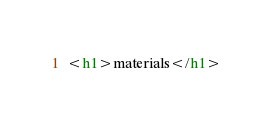<code> <loc_0><loc_0><loc_500><loc_500><_HTML_><h1>materials</h1>
</code> 